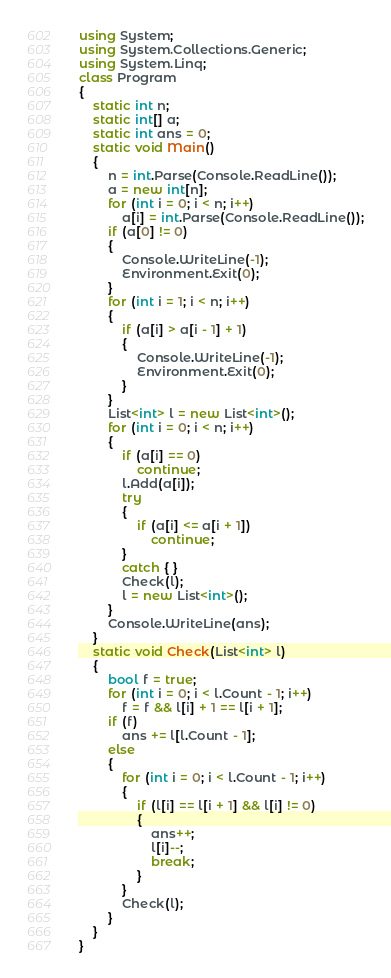Convert code to text. <code><loc_0><loc_0><loc_500><loc_500><_C#_>using System;
using System.Collections.Generic;
using System.Linq;
class Program
{
    static int n;
    static int[] a;
    static int ans = 0;
    static void Main()
    {
        n = int.Parse(Console.ReadLine());
        a = new int[n];
        for (int i = 0; i < n; i++)
            a[i] = int.Parse(Console.ReadLine());
        if (a[0] != 0)
        {
            Console.WriteLine(-1);
            Environment.Exit(0);
        }
        for (int i = 1; i < n; i++)
        {
            if (a[i] > a[i - 1] + 1)
            {
                Console.WriteLine(-1);
                Environment.Exit(0);
            }
        }
        List<int> l = new List<int>();
        for (int i = 0; i < n; i++)
        {
            if (a[i] == 0)
                continue;
            l.Add(a[i]);
            try
            {
                if (a[i] <= a[i + 1])
                    continue;
            }
            catch { }
            Check(l);
            l = new List<int>();
        }
        Console.WriteLine(ans);
    }
    static void Check(List<int> l)
    {
        bool f = true;
        for (int i = 0; i < l.Count - 1; i++)
            f = f && l[i] + 1 == l[i + 1];
        if (f)
            ans += l[l.Count - 1];
        else
        {
            for (int i = 0; i < l.Count - 1; i++)
            {
                if (l[i] == l[i + 1] && l[i] != 0)
                {
                    ans++;
                    l[i]--;
                    break;
                }
            }
            Check(l);
        }
    }
}</code> 